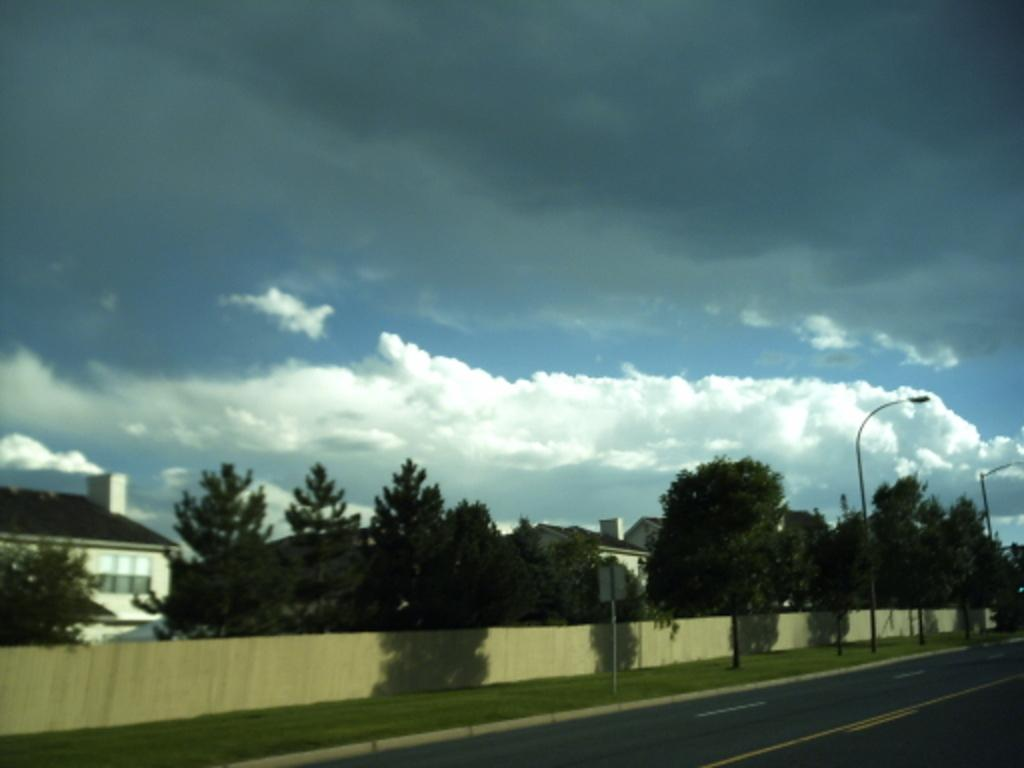What type of natural elements can be seen in the image? There are trees in the image. What type of man-made structures are present in the image? There are houses in the image. What type of transportation infrastructure is visible in the image? There is a road in the image. What part of the natural environment is visible in the image? The sky is visible in the image. Can you tell me how many people are swimming in the image? There is no swimming activity depicted in the image; it features trees, houses, a road, and the sky. What type of clothing is worn by the people in the house in the image? There are no people visible inside the houses in the image, so it is not possible to determine what type of clothing they might be wearing. 